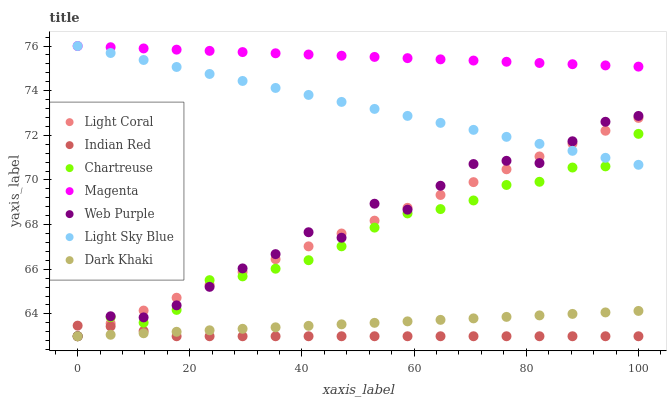Does Indian Red have the minimum area under the curve?
Answer yes or no. Yes. Does Magenta have the maximum area under the curve?
Answer yes or no. Yes. Does Chartreuse have the minimum area under the curve?
Answer yes or no. No. Does Chartreuse have the maximum area under the curve?
Answer yes or no. No. Is Magenta the smoothest?
Answer yes or no. Yes. Is Web Purple the roughest?
Answer yes or no. Yes. Is Chartreuse the smoothest?
Answer yes or no. No. Is Chartreuse the roughest?
Answer yes or no. No. Does Dark Khaki have the lowest value?
Answer yes or no. Yes. Does Light Sky Blue have the lowest value?
Answer yes or no. No. Does Magenta have the highest value?
Answer yes or no. Yes. Does Chartreuse have the highest value?
Answer yes or no. No. Is Indian Red less than Light Sky Blue?
Answer yes or no. Yes. Is Light Sky Blue greater than Indian Red?
Answer yes or no. Yes. Does Light Sky Blue intersect Web Purple?
Answer yes or no. Yes. Is Light Sky Blue less than Web Purple?
Answer yes or no. No. Is Light Sky Blue greater than Web Purple?
Answer yes or no. No. Does Indian Red intersect Light Sky Blue?
Answer yes or no. No. 